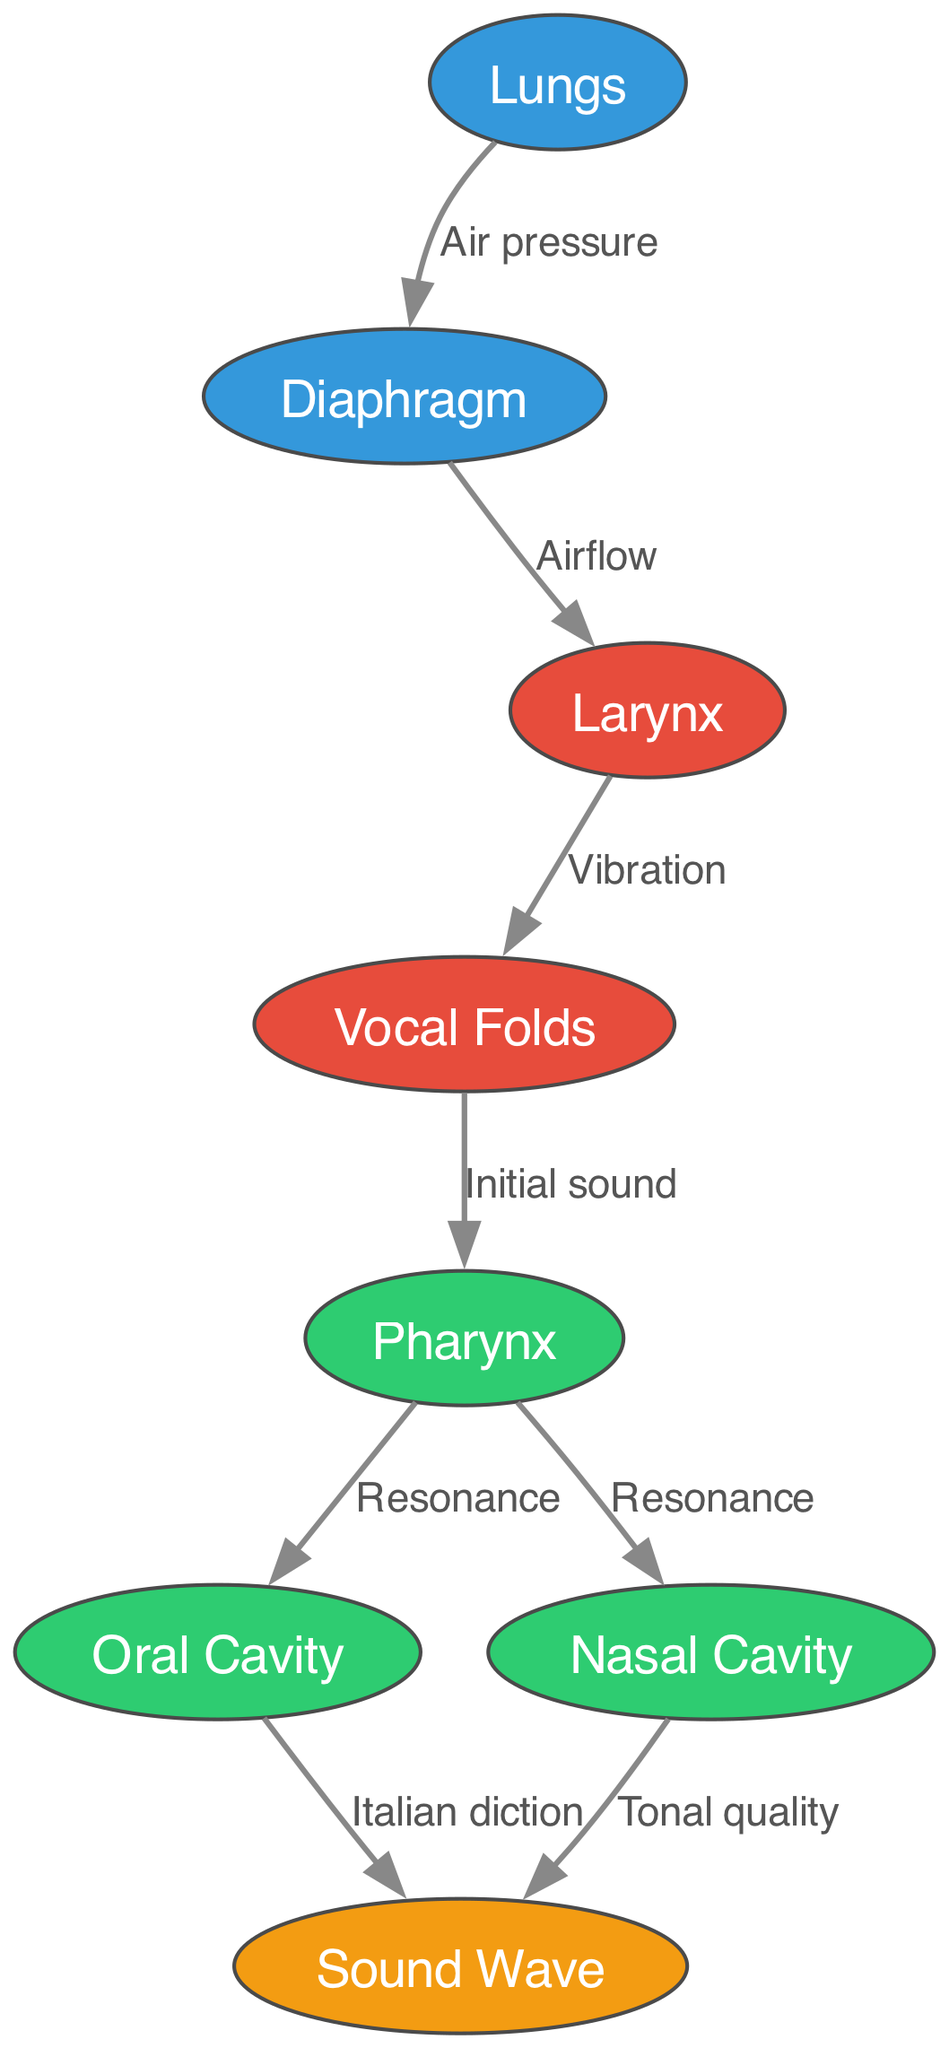What is the starting point of air pressure in the diagram? The starting point of air pressure is indicated by the "Lungs" node, which is where the air is stored and pushed out through the diaphragm.
Answer: Lungs How many nodes are represented in the diagram? By counting the distinct entities present, we can see there are 8 nodes: Lungs, Diaphragm, Larynx, Vocal Folds, Pharynx, Oral Cavity, Nasal Cavity, and Sound Wave.
Answer: 8 What follows the vibration of vocal folds in the sound production process? After the vibration of the vocal folds, the initial sound is directed towards the pharynx, which is the next node in the sequence.
Answer: Pharynx Which two cavities contribute to producing the final sound wave? The final sound wave is produced from both the Oral Cavity and the Nasal Cavity, as indicated by the connections leading to the Sound Wave node.
Answer: Oral Cavity and Nasal Cavity What type of relationship exists between the diaphragm and the larynx? The relationship from the diaphragm to the larynx is labeled "Airflow," indicating that the diaphragm controls airflow towards the larynx for sound production.
Answer: Airflow Which component directly vibrates to initiate sound production? The component that directly vibrates to initiate sound production is the "Vocal Folds," as shown in the diagram as the point of vibration after airflow from the diaphragm enters the larynx.
Answer: Vocal Folds How does resonance occur in this diagram? Resonance occurs when the initial sound travels from the pharynx to both the oral cavity and nasal cavity, reflecting the way sound is amplified and modified in those spaces.
Answer: Pharynx What is the labeled impact of the oral cavity on the sound wave? The labeled impact of the oral cavity on the sound wave is described as "Italian diction," emphasizing its role in shaping the clarity and character of the sound produced.
Answer: Italian diction 